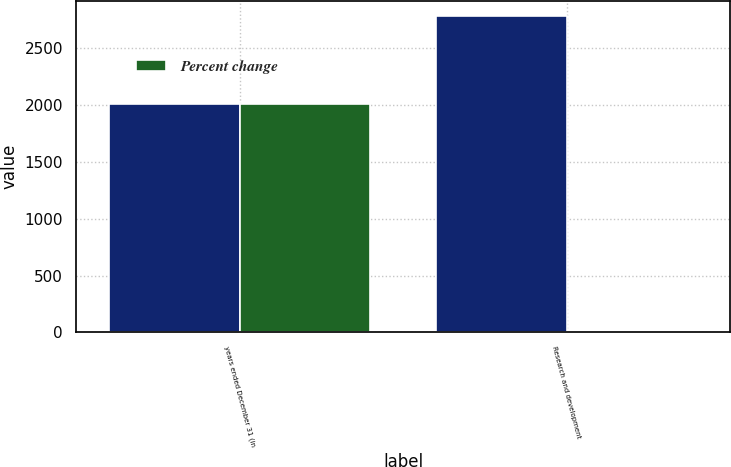<chart> <loc_0><loc_0><loc_500><loc_500><stacked_bar_chart><ecel><fcel>years ended December 31 (in<fcel>Research and development<nl><fcel>nan<fcel>2012<fcel>2778<nl><fcel>Percent change<fcel>2012<fcel>6<nl></chart> 